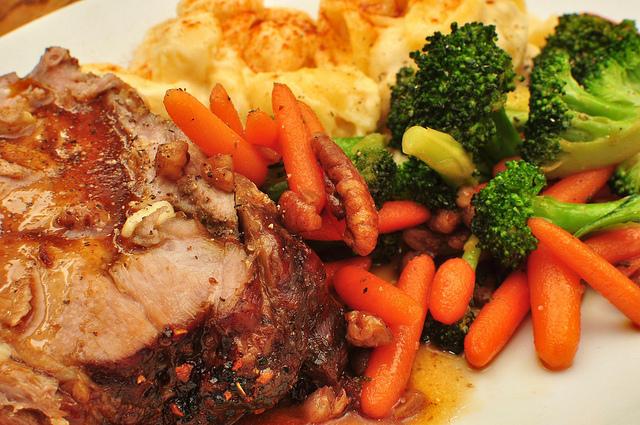What is the meat on the left?
Keep it brief. Pork. Is this a display?
Short answer required. No. What is green on the plate?
Be succinct. Broccoli. 